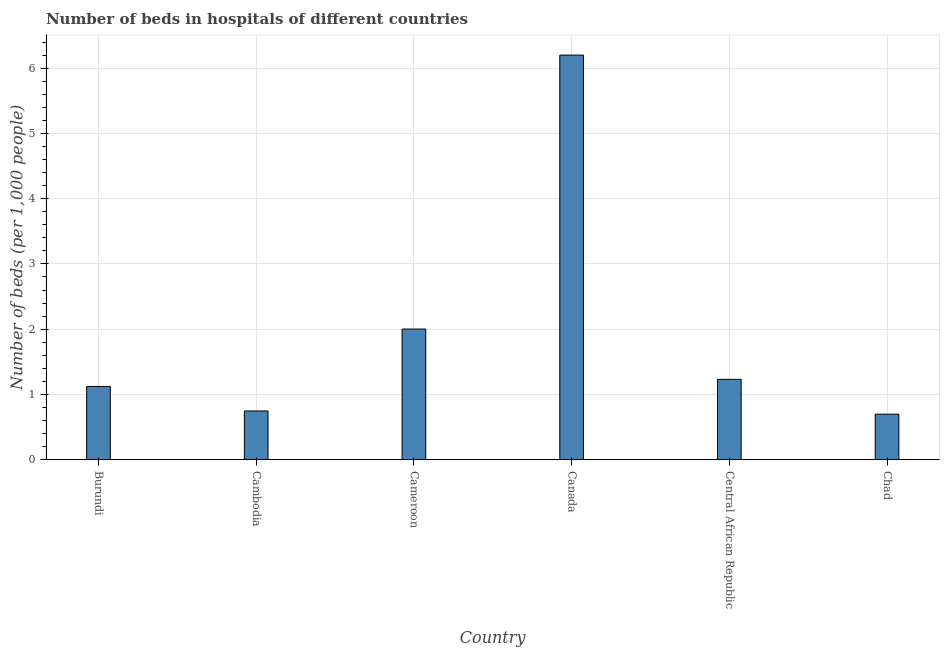Does the graph contain grids?
Offer a very short reply. Yes. What is the title of the graph?
Your response must be concise. Number of beds in hospitals of different countries. What is the label or title of the X-axis?
Offer a terse response. Country. What is the label or title of the Y-axis?
Offer a terse response. Number of beds (per 1,0 people). What is the number of hospital beds in Central African Republic?
Ensure brevity in your answer.  1.23. Across all countries, what is the maximum number of hospital beds?
Keep it short and to the point. 6.2. Across all countries, what is the minimum number of hospital beds?
Offer a terse response. 0.7. In which country was the number of hospital beds maximum?
Give a very brief answer. Canada. In which country was the number of hospital beds minimum?
Your answer should be compact. Chad. What is the sum of the number of hospital beds?
Your answer should be very brief. 12. What is the difference between the number of hospital beds in Burundi and Canada?
Ensure brevity in your answer.  -5.08. What is the average number of hospital beds per country?
Make the answer very short. 2. What is the median number of hospital beds?
Your response must be concise. 1.18. What is the ratio of the number of hospital beds in Cambodia to that in Canada?
Your answer should be compact. 0.12. Is the number of hospital beds in Burundi less than that in Central African Republic?
Your answer should be very brief. Yes. Is the difference between the number of hospital beds in Cameroon and Chad greater than the difference between any two countries?
Provide a succinct answer. No. What is the difference between the highest and the second highest number of hospital beds?
Offer a very short reply. 4.2. How many countries are there in the graph?
Provide a succinct answer. 6. What is the difference between two consecutive major ticks on the Y-axis?
Keep it short and to the point. 1. Are the values on the major ticks of Y-axis written in scientific E-notation?
Offer a terse response. No. What is the Number of beds (per 1,000 people) of Burundi?
Provide a succinct answer. 1.12. What is the Number of beds (per 1,000 people) in Cambodia?
Make the answer very short. 0.75. What is the Number of beds (per 1,000 people) in Cameroon?
Provide a short and direct response. 2. What is the Number of beds (per 1,000 people) in Canada?
Make the answer very short. 6.2. What is the Number of beds (per 1,000 people) in Central African Republic?
Your answer should be compact. 1.23. What is the Number of beds (per 1,000 people) in Chad?
Provide a succinct answer. 0.7. What is the difference between the Number of beds (per 1,000 people) in Burundi and Cambodia?
Provide a succinct answer. 0.38. What is the difference between the Number of beds (per 1,000 people) in Burundi and Cameroon?
Offer a terse response. -0.88. What is the difference between the Number of beds (per 1,000 people) in Burundi and Canada?
Offer a very short reply. -5.08. What is the difference between the Number of beds (per 1,000 people) in Burundi and Central African Republic?
Provide a short and direct response. -0.11. What is the difference between the Number of beds (per 1,000 people) in Burundi and Chad?
Offer a terse response. 0.42. What is the difference between the Number of beds (per 1,000 people) in Cambodia and Cameroon?
Ensure brevity in your answer.  -1.26. What is the difference between the Number of beds (per 1,000 people) in Cambodia and Canada?
Keep it short and to the point. -5.45. What is the difference between the Number of beds (per 1,000 people) in Cambodia and Central African Republic?
Your answer should be compact. -0.48. What is the difference between the Number of beds (per 1,000 people) in Cambodia and Chad?
Give a very brief answer. 0.05. What is the difference between the Number of beds (per 1,000 people) in Cameroon and Canada?
Your answer should be very brief. -4.2. What is the difference between the Number of beds (per 1,000 people) in Cameroon and Central African Republic?
Provide a short and direct response. 0.77. What is the difference between the Number of beds (per 1,000 people) in Cameroon and Chad?
Offer a very short reply. 1.3. What is the difference between the Number of beds (per 1,000 people) in Canada and Central African Republic?
Your response must be concise. 4.97. What is the difference between the Number of beds (per 1,000 people) in Canada and Chad?
Ensure brevity in your answer.  5.5. What is the difference between the Number of beds (per 1,000 people) in Central African Republic and Chad?
Provide a short and direct response. 0.53. What is the ratio of the Number of beds (per 1,000 people) in Burundi to that in Cambodia?
Offer a terse response. 1.5. What is the ratio of the Number of beds (per 1,000 people) in Burundi to that in Cameroon?
Provide a succinct answer. 0.56. What is the ratio of the Number of beds (per 1,000 people) in Burundi to that in Canada?
Offer a very short reply. 0.18. What is the ratio of the Number of beds (per 1,000 people) in Burundi to that in Central African Republic?
Your answer should be compact. 0.91. What is the ratio of the Number of beds (per 1,000 people) in Burundi to that in Chad?
Provide a short and direct response. 1.61. What is the ratio of the Number of beds (per 1,000 people) in Cambodia to that in Cameroon?
Make the answer very short. 0.37. What is the ratio of the Number of beds (per 1,000 people) in Cambodia to that in Canada?
Provide a succinct answer. 0.12. What is the ratio of the Number of beds (per 1,000 people) in Cambodia to that in Central African Republic?
Your answer should be very brief. 0.61. What is the ratio of the Number of beds (per 1,000 people) in Cambodia to that in Chad?
Offer a very short reply. 1.07. What is the ratio of the Number of beds (per 1,000 people) in Cameroon to that in Canada?
Your response must be concise. 0.32. What is the ratio of the Number of beds (per 1,000 people) in Cameroon to that in Central African Republic?
Provide a succinct answer. 1.63. What is the ratio of the Number of beds (per 1,000 people) in Cameroon to that in Chad?
Offer a terse response. 2.87. What is the ratio of the Number of beds (per 1,000 people) in Canada to that in Central African Republic?
Your response must be concise. 5.04. What is the ratio of the Number of beds (per 1,000 people) in Canada to that in Chad?
Offer a terse response. 8.89. What is the ratio of the Number of beds (per 1,000 people) in Central African Republic to that in Chad?
Offer a very short reply. 1.77. 